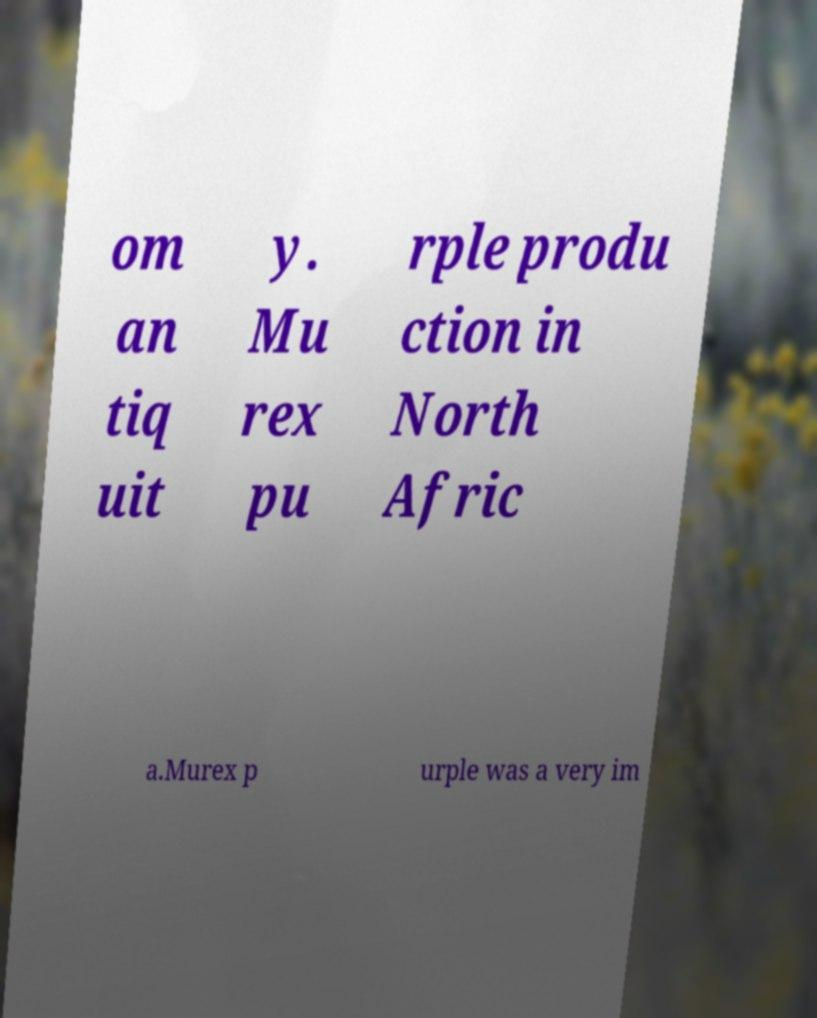Please read and relay the text visible in this image. What does it say? om an tiq uit y. Mu rex pu rple produ ction in North Afric a.Murex p urple was a very im 